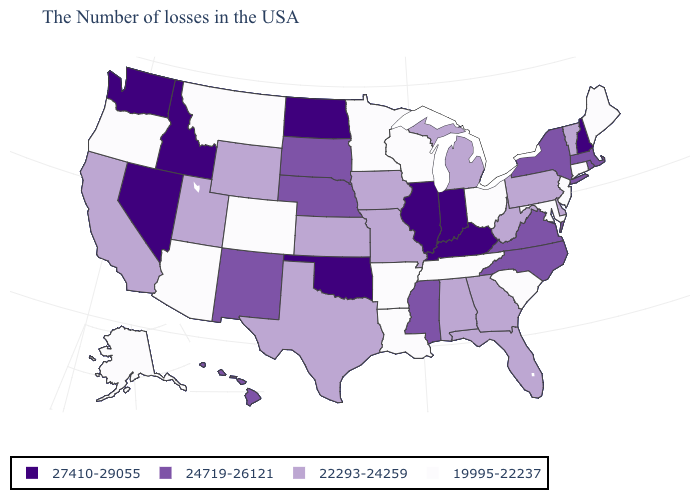What is the highest value in the USA?
Quick response, please. 27410-29055. Does Virginia have a lower value than Nevada?
Give a very brief answer. Yes. Among the states that border Massachusetts , which have the lowest value?
Short answer required. Connecticut. Name the states that have a value in the range 27410-29055?
Concise answer only. New Hampshire, Kentucky, Indiana, Illinois, Oklahoma, North Dakota, Idaho, Nevada, Washington. Does New Hampshire have the lowest value in the Northeast?
Short answer required. No. What is the value of Alabama?
Short answer required. 22293-24259. What is the lowest value in states that border Illinois?
Be succinct. 19995-22237. What is the value of Wisconsin?
Concise answer only. 19995-22237. Among the states that border North Carolina , which have the lowest value?
Quick response, please. South Carolina, Tennessee. Name the states that have a value in the range 24719-26121?
Short answer required. Massachusetts, Rhode Island, New York, Virginia, North Carolina, Mississippi, Nebraska, South Dakota, New Mexico, Hawaii. Which states have the lowest value in the USA?
Answer briefly. Maine, Connecticut, New Jersey, Maryland, South Carolina, Ohio, Tennessee, Wisconsin, Louisiana, Arkansas, Minnesota, Colorado, Montana, Arizona, Oregon, Alaska. What is the value of Virginia?
Concise answer only. 24719-26121. Does North Dakota have the highest value in the MidWest?
Write a very short answer. Yes. What is the value of Hawaii?
Keep it brief. 24719-26121. What is the value of Washington?
Answer briefly. 27410-29055. 